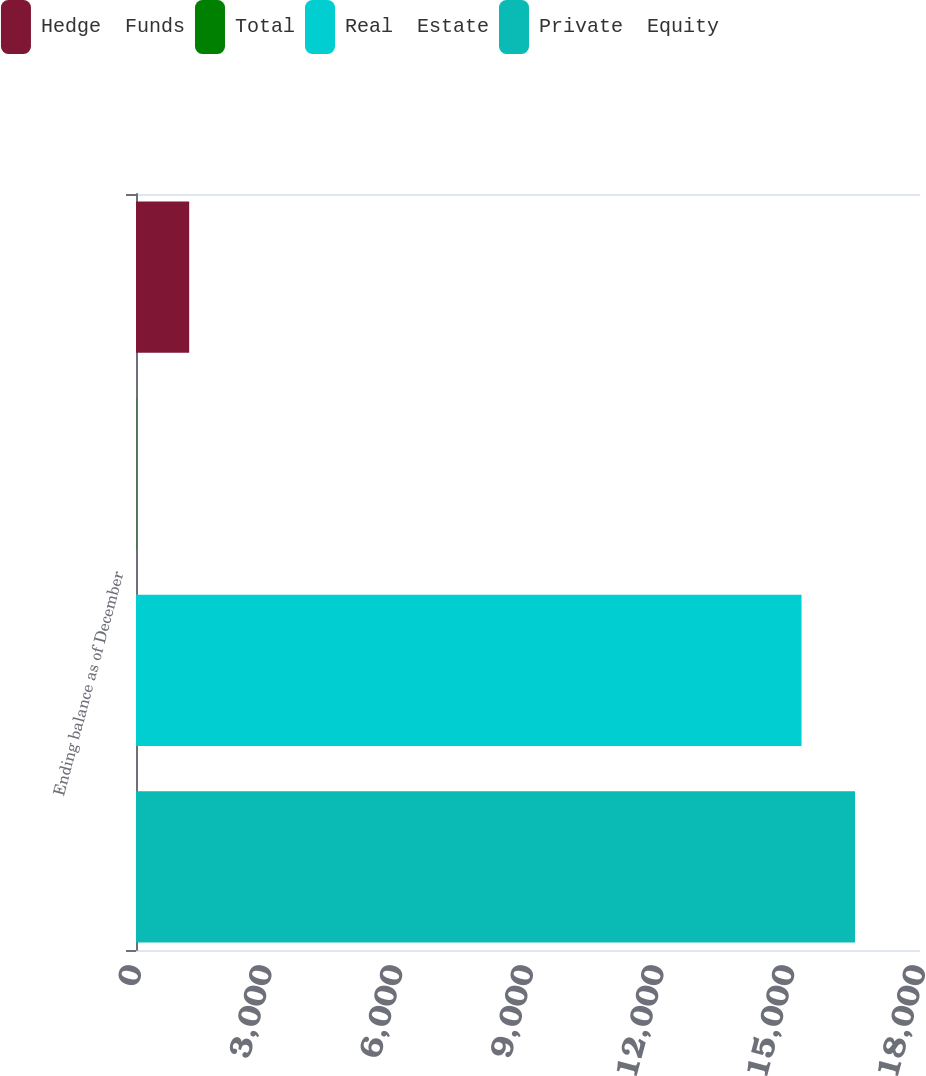Convert chart. <chart><loc_0><loc_0><loc_500><loc_500><stacked_bar_chart><ecel><fcel>Ending balance as of December<nl><fcel>Hedge  Funds<fcel>1221<nl><fcel>Total<fcel>7<nl><fcel>Real  Estate<fcel>15280<nl><fcel>Private  Equity<fcel>16508<nl></chart> 